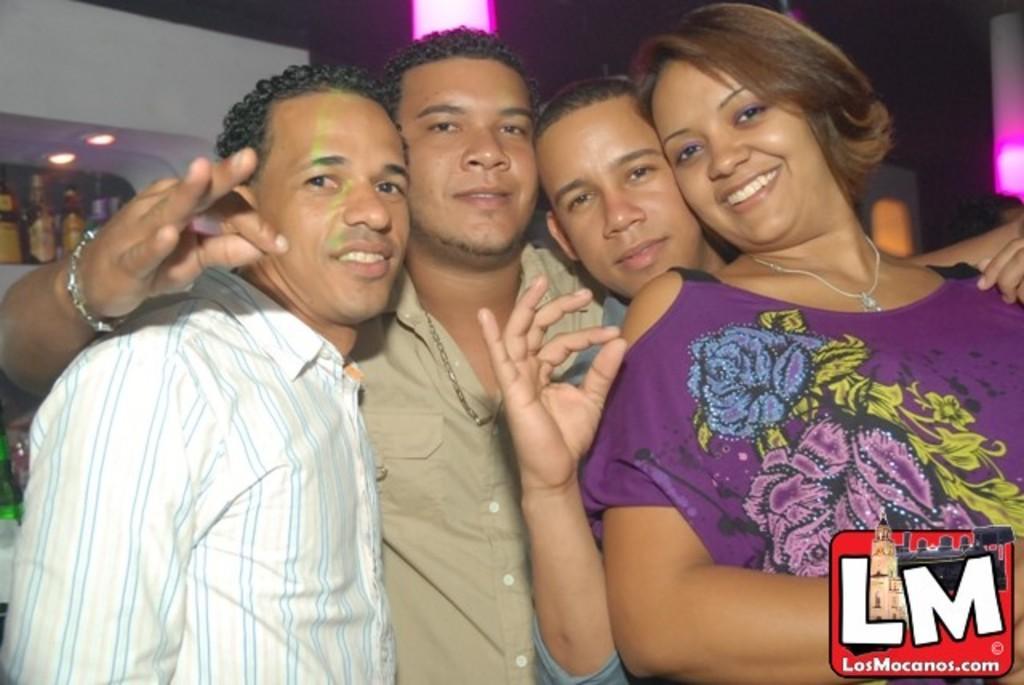Describe this image in one or two sentences. In this image we can see a few people, behind there are a few bottles, at the bottom there is a written text. 